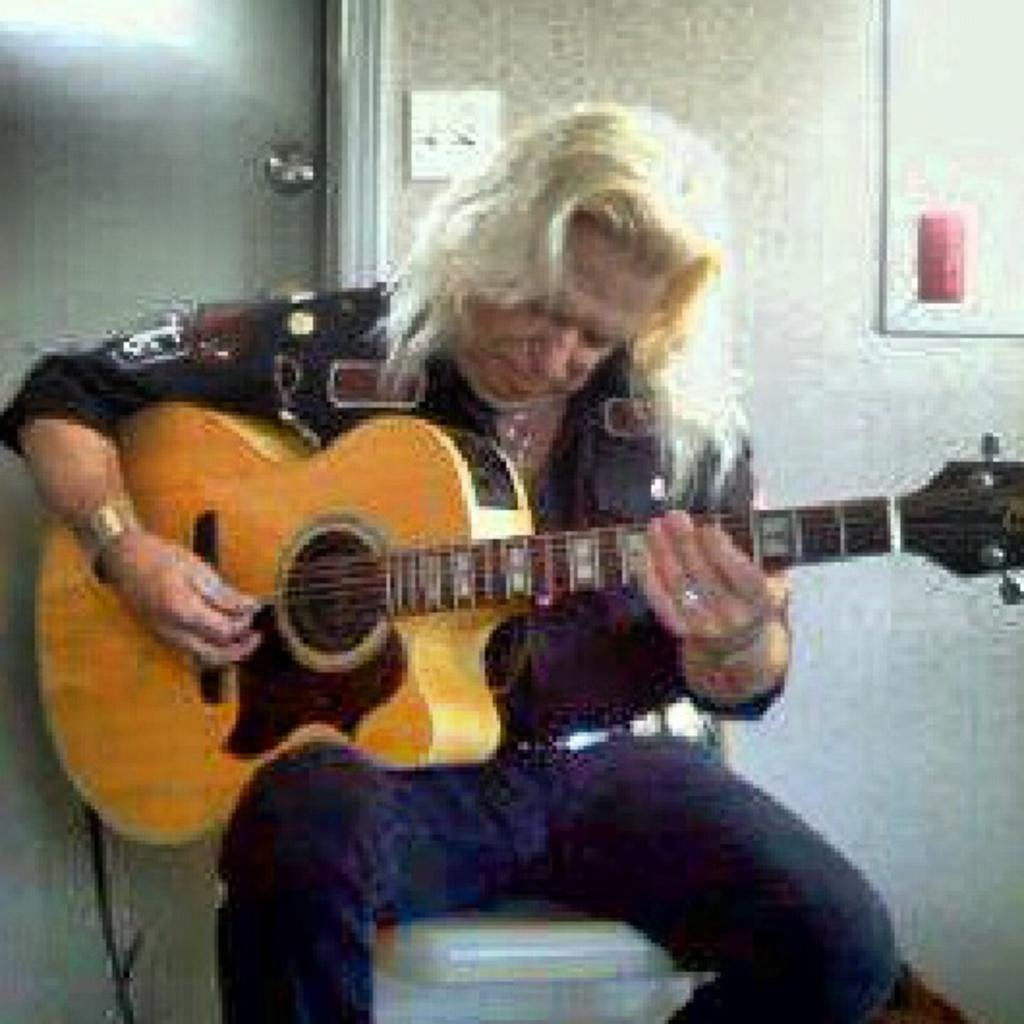What is the main subject of the image? The main subject of the image is a person. What is the person doing in the image? The person is playing a guitar. What type of heat source can be seen in the image? There is no heat source present in the image. What type of glass object is visible in the image? There is no glass object present in the image. What type of bridge can be seen in the image? There is no bridge present in the image. 